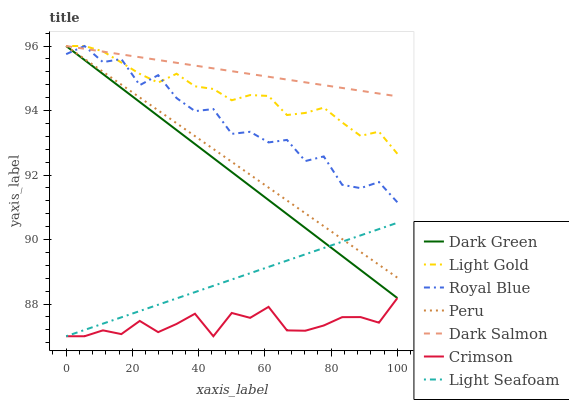Does Crimson have the minimum area under the curve?
Answer yes or no. Yes. Does Dark Salmon have the maximum area under the curve?
Answer yes or no. Yes. Does Royal Blue have the minimum area under the curve?
Answer yes or no. No. Does Royal Blue have the maximum area under the curve?
Answer yes or no. No. Is Dark Salmon the smoothest?
Answer yes or no. Yes. Is Royal Blue the roughest?
Answer yes or no. Yes. Is Peru the smoothest?
Answer yes or no. No. Is Peru the roughest?
Answer yes or no. No. Does Royal Blue have the lowest value?
Answer yes or no. No. Does Dark Green have the highest value?
Answer yes or no. Yes. Does Crimson have the highest value?
Answer yes or no. No. Is Crimson less than Dark Green?
Answer yes or no. Yes. Is Light Gold greater than Crimson?
Answer yes or no. Yes. Does Dark Green intersect Light Seafoam?
Answer yes or no. Yes. Is Dark Green less than Light Seafoam?
Answer yes or no. No. Is Dark Green greater than Light Seafoam?
Answer yes or no. No. Does Crimson intersect Dark Green?
Answer yes or no. No. 